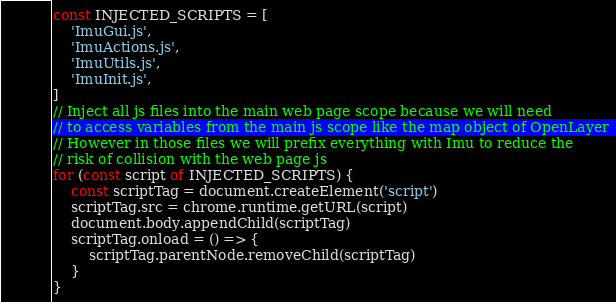<code> <loc_0><loc_0><loc_500><loc_500><_JavaScript_>const INJECTED_SCRIPTS = [
    'ImuGui.js',
    'ImuActions.js',
    'ImuUtils.js',
    'ImuInit.js',
]
// Inject all js files into the main web page scope because we will need
// to access variables from the main js scope like the map object of OpenLayer
// However in those files we will prefix everything with Imu to reduce the
// risk of collision with the web page js
for (const script of INJECTED_SCRIPTS) {
    const scriptTag = document.createElement('script')
    scriptTag.src = chrome.runtime.getURL(script)
    document.body.appendChild(scriptTag)
    scriptTag.onload = () => {
        scriptTag.parentNode.removeChild(scriptTag)
    }
}</code> 